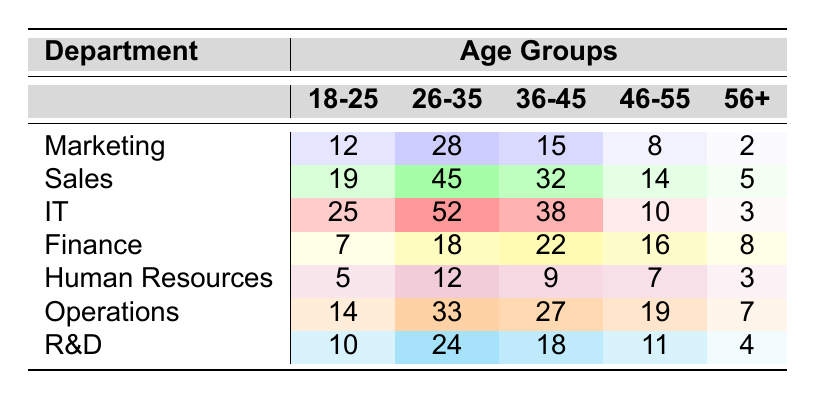What is the age group with the highest number of employees in the IT department? In the IT department, the age groups have the following employee counts: 18-25: 25, 26-35: 52, 36-45: 38, 46-55: 10, and 56+: 3. The highest count is in the 26-35 age group with 52 employees.
Answer: 26-35 Which department has the lowest number of employees in the 56+ age group? The counts for the 56+ age group across departments are: Marketing: 2, Sales: 5, IT: 3, Finance: 8, Human Resources: 3, Operations: 7, and R&D: 4. The lowest count is in the Marketing department with 2 employees.
Answer: Marketing What is the total number of employees aged 18-25 across all departments? The counts for the 18-25 age group in all departments are: Marketing: 12, Sales: 19, IT: 25, Finance: 7, Human Resources: 5, Operations: 14, and R&D: 10. Summing these gives: 12 + 19 + 25 + 7 + 5 + 14 + 10 = 92.
Answer: 92 Which age group has the highest total number of employees across all departments? To find the age group with the highest total count, we sum the employees for each age group across departments: 18-25: 12 + 19 + 25 + 7 + 5 + 14 + 10 = 92, 26-35: 28 + 45 + 52 + 18 + 12 + 33 + 24 = 212, 36-45: 15 + 32 + 38 + 22 + 9 + 27 + 18 = 161, 46-55: 8 + 14 + 10 + 16 + 7 + 19 + 11 = 85, 56+: 2 + 5 + 3 + 8 + 3 + 7 + 4 = 32. The highest total is in the 26-35 age group with 212 employees.
Answer: 26-35 Is the number of employees in the 36-45 age group in the Sales department greater than that in the Finance department? The counts for the 36-45 age group are: Sales: 32 and Finance: 22. Since 32 is greater than 22, the statement is true.
Answer: Yes What is the combined number of employees aged 46-55 in the Marketing and Human Resources departments? The counts for the 46-55 age group are: Marketing: 8 and Human Resources: 7. Their combined total is 8 + 7 = 15.
Answer: 15 Calculate the average number of employees in the 26-35 age group across all departments. The counts for the 26-35 age group are: Marketing: 28, Sales: 45, IT: 52, Finance: 18, Human Resources: 12, Operations: 33, and R&D: 24. This sums to 28 + 45 + 52 + 18 + 12 + 33 + 24 = 212. There are 7 departments, so the average is 212 / 7 ≈ 30.29.
Answer: ~30.29 How many more employees are there aged 18-25 in IT than in Finance? The counts for the 18-25 age group are: IT: 25 and Finance: 7. The difference is 25 - 7 = 18.
Answer: 18 Which department has the most balanced age distribution based on all the age groups? This requires comparing the standard deviation or the distribution across each department. After reviewing each age group and the distribution, the Operations department shows the most evenly distributed counts across age groups.
Answer: Operations 